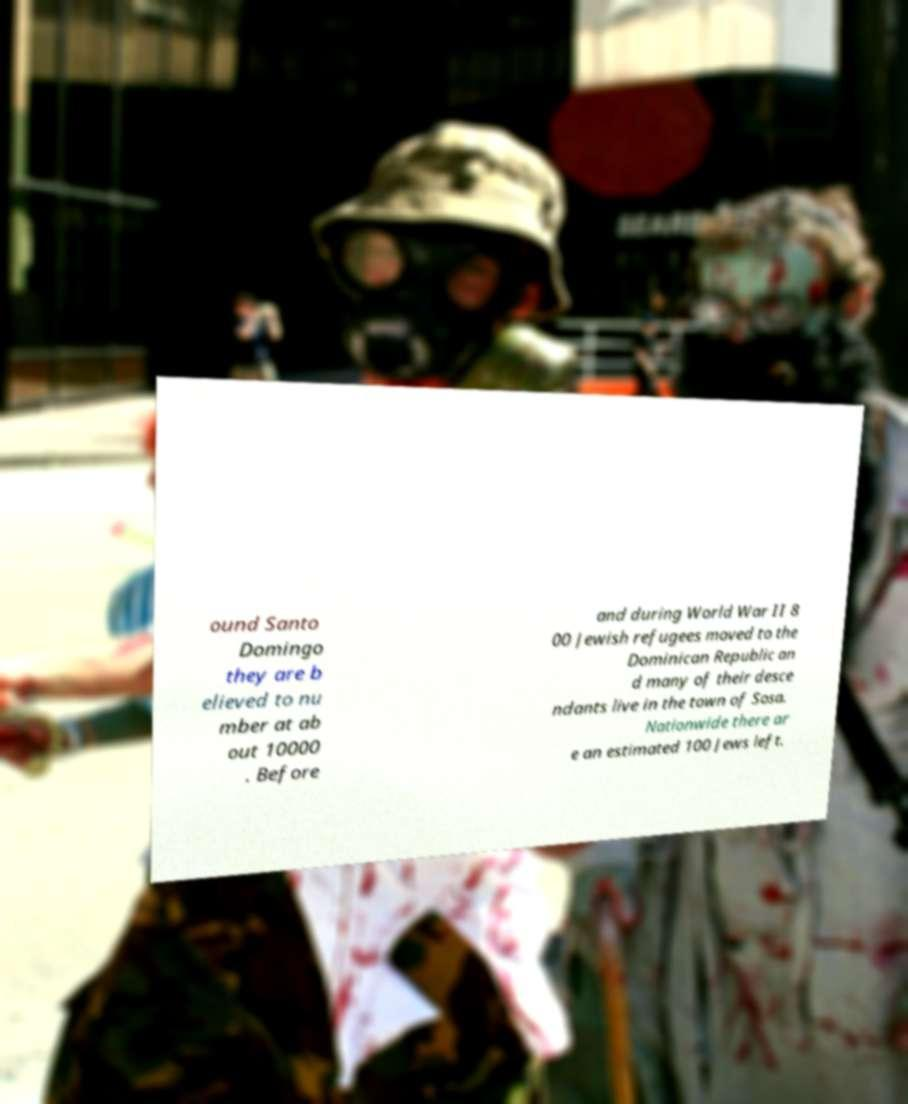Could you assist in decoding the text presented in this image and type it out clearly? ound Santo Domingo they are b elieved to nu mber at ab out 10000 . Before and during World War II 8 00 Jewish refugees moved to the Dominican Republic an d many of their desce ndants live in the town of Sosa. Nationwide there ar e an estimated 100 Jews left. 